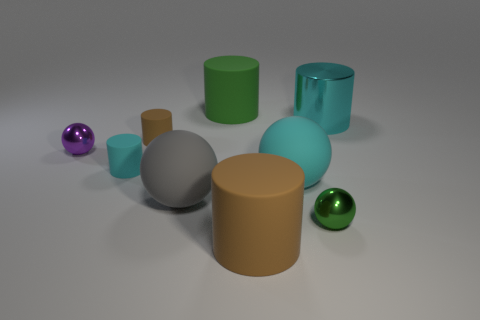Subtract all green cylinders. How many cylinders are left? 4 Subtract all cyan matte cylinders. How many cylinders are left? 4 Subtract all red spheres. Subtract all cyan cylinders. How many spheres are left? 4 Add 1 small red matte objects. How many objects exist? 10 Subtract all cylinders. How many objects are left? 4 Subtract 0 blue cylinders. How many objects are left? 9 Subtract all green matte objects. Subtract all tiny brown cylinders. How many objects are left? 7 Add 2 large gray matte objects. How many large gray matte objects are left? 3 Add 8 gray matte objects. How many gray matte objects exist? 9 